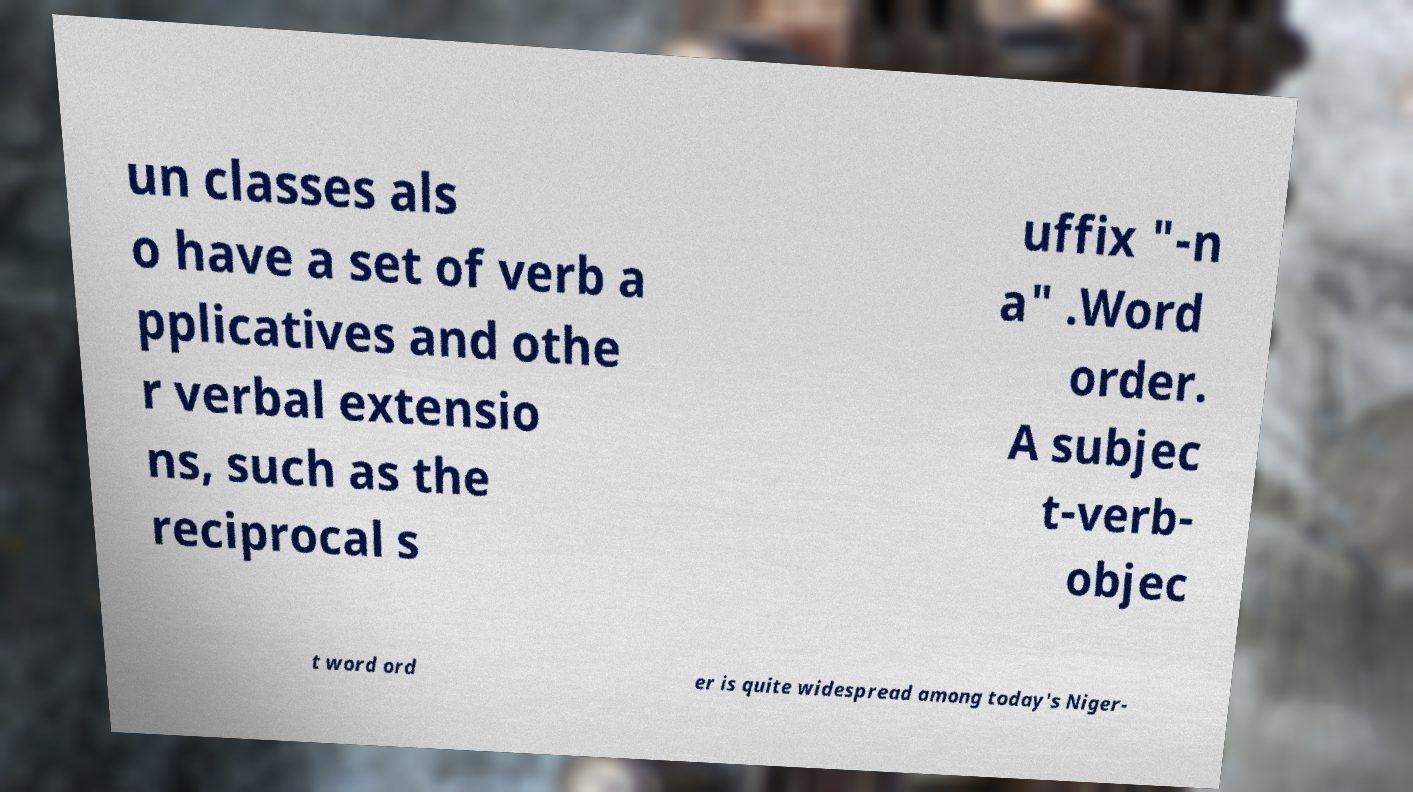Could you extract and type out the text from this image? un classes als o have a set of verb a pplicatives and othe r verbal extensio ns, such as the reciprocal s uffix "-n a" .Word order. A subjec t-verb- objec t word ord er is quite widespread among today's Niger- 